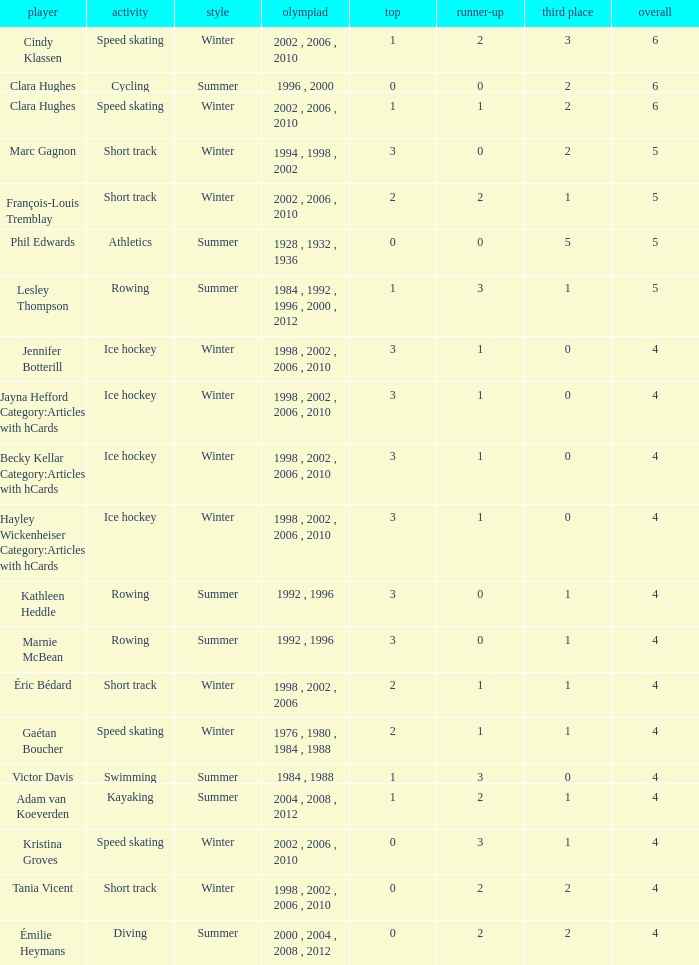Could you help me parse every detail presented in this table? {'header': ['player', 'activity', 'style', 'olympiad', 'top', 'runner-up', 'third place', 'overall'], 'rows': [['Cindy Klassen', 'Speed skating', 'Winter', '2002 , 2006 , 2010', '1', '2', '3', '6'], ['Clara Hughes', 'Cycling', 'Summer', '1996 , 2000', '0', '0', '2', '6'], ['Clara Hughes', 'Speed skating', 'Winter', '2002 , 2006 , 2010', '1', '1', '2', '6'], ['Marc Gagnon', 'Short track', 'Winter', '1994 , 1998 , 2002', '3', '0', '2', '5'], ['François-Louis Tremblay', 'Short track', 'Winter', '2002 , 2006 , 2010', '2', '2', '1', '5'], ['Phil Edwards', 'Athletics', 'Summer', '1928 , 1932 , 1936', '0', '0', '5', '5'], ['Lesley Thompson', 'Rowing', 'Summer', '1984 , 1992 , 1996 , 2000 , 2012', '1', '3', '1', '5'], ['Jennifer Botterill', 'Ice hockey', 'Winter', '1998 , 2002 , 2006 , 2010', '3', '1', '0', '4'], ['Jayna Hefford Category:Articles with hCards', 'Ice hockey', 'Winter', '1998 , 2002 , 2006 , 2010', '3', '1', '0', '4'], ['Becky Kellar Category:Articles with hCards', 'Ice hockey', 'Winter', '1998 , 2002 , 2006 , 2010', '3', '1', '0', '4'], ['Hayley Wickenheiser Category:Articles with hCards', 'Ice hockey', 'Winter', '1998 , 2002 , 2006 , 2010', '3', '1', '0', '4'], ['Kathleen Heddle', 'Rowing', 'Summer', '1992 , 1996', '3', '0', '1', '4'], ['Marnie McBean', 'Rowing', 'Summer', '1992 , 1996', '3', '0', '1', '4'], ['Éric Bédard', 'Short track', 'Winter', '1998 , 2002 , 2006', '2', '1', '1', '4'], ['Gaétan Boucher', 'Speed skating', 'Winter', '1976 , 1980 , 1984 , 1988', '2', '1', '1', '4'], ['Victor Davis', 'Swimming', 'Summer', '1984 , 1988', '1', '3', '0', '4'], ['Adam van Koeverden', 'Kayaking', 'Summer', '2004 , 2008 , 2012', '1', '2', '1', '4'], ['Kristina Groves', 'Speed skating', 'Winter', '2002 , 2006 , 2010', '0', '3', '1', '4'], ['Tania Vicent', 'Short track', 'Winter', '1998 , 2002 , 2006 , 2010', '0', '2', '2', '4'], ['Émilie Heymans', 'Diving', 'Summer', '2000 , 2004 , 2008 , 2012', '0', '2', '2', '4']]} What is the highest total medals winter athlete Clara Hughes has? 6.0. 